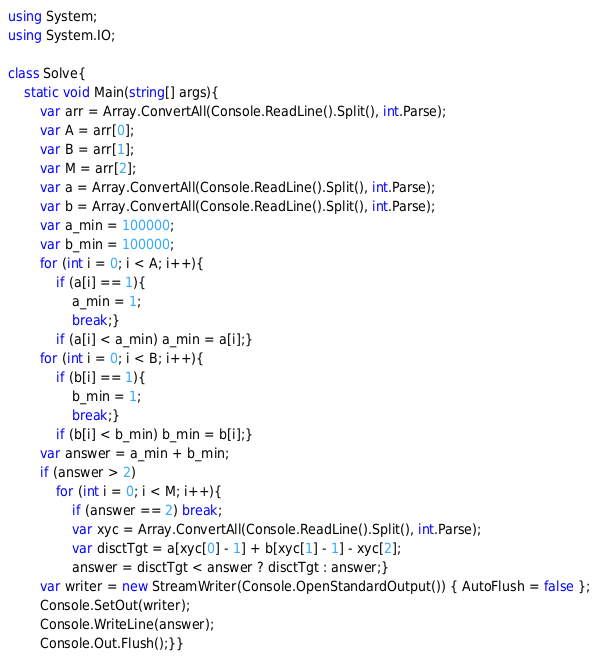Convert code to text. <code><loc_0><loc_0><loc_500><loc_500><_C#_>using System;
using System.IO;

class Solve{
    static void Main(string[] args){
        var arr = Array.ConvertAll(Console.ReadLine().Split(), int.Parse);
        var A = arr[0];
        var B = arr[1];
        var M = arr[2];
        var a = Array.ConvertAll(Console.ReadLine().Split(), int.Parse);
        var b = Array.ConvertAll(Console.ReadLine().Split(), int.Parse);
        var a_min = 100000;
        var b_min = 100000;
        for (int i = 0; i < A; i++){
            if (a[i] == 1){
                a_min = 1;
                break;}
            if (a[i] < a_min) a_min = a[i];}
        for (int i = 0; i < B; i++){
            if (b[i] == 1){
                b_min = 1;
                break;}
            if (b[i] < b_min) b_min = b[i];}
        var answer = a_min + b_min;
        if (answer > 2)
            for (int i = 0; i < M; i++){
                if (answer == 2) break;
                var xyc = Array.ConvertAll(Console.ReadLine().Split(), int.Parse);
                var disctTgt = a[xyc[0] - 1] + b[xyc[1] - 1] - xyc[2];
                answer = disctTgt < answer ? disctTgt : answer;}
        var writer = new StreamWriter(Console.OpenStandardOutput()) { AutoFlush = false };
        Console.SetOut(writer);
        Console.WriteLine(answer);
        Console.Out.Flush();}}</code> 